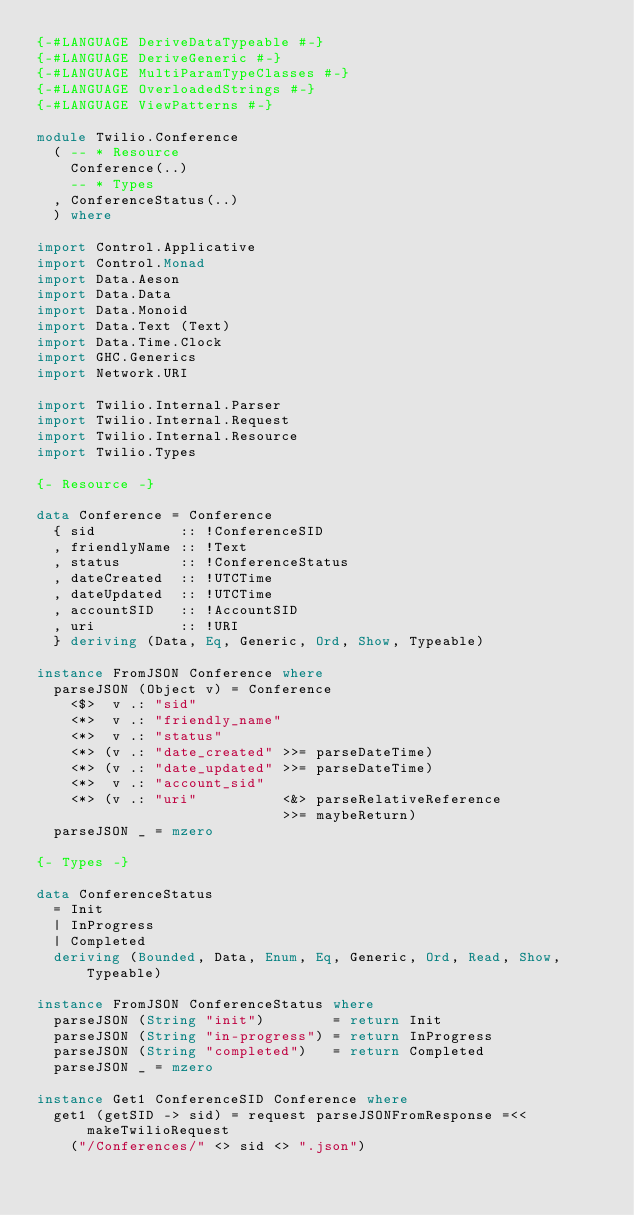Convert code to text. <code><loc_0><loc_0><loc_500><loc_500><_Haskell_>{-#LANGUAGE DeriveDataTypeable #-}
{-#LANGUAGE DeriveGeneric #-}
{-#LANGUAGE MultiParamTypeClasses #-}
{-#LANGUAGE OverloadedStrings #-}
{-#LANGUAGE ViewPatterns #-}

module Twilio.Conference
  ( -- * Resource
    Conference(..)
    -- * Types
  , ConferenceStatus(..)
  ) where

import Control.Applicative
import Control.Monad
import Data.Aeson
import Data.Data
import Data.Monoid
import Data.Text (Text)
import Data.Time.Clock
import GHC.Generics
import Network.URI

import Twilio.Internal.Parser
import Twilio.Internal.Request
import Twilio.Internal.Resource
import Twilio.Types

{- Resource -}

data Conference = Conference
  { sid          :: !ConferenceSID
  , friendlyName :: !Text
  , status       :: !ConferenceStatus
  , dateCreated  :: !UTCTime
  , dateUpdated  :: !UTCTime
  , accountSID   :: !AccountSID
  , uri          :: !URI
  } deriving (Data, Eq, Generic, Ord, Show, Typeable)

instance FromJSON Conference where
  parseJSON (Object v) = Conference
    <$>  v .: "sid"
    <*>  v .: "friendly_name"
    <*>  v .: "status"
    <*> (v .: "date_created" >>= parseDateTime)
    <*> (v .: "date_updated" >>= parseDateTime)
    <*>  v .: "account_sid"
    <*> (v .: "uri"          <&> parseRelativeReference
                             >>= maybeReturn)
  parseJSON _ = mzero

{- Types -}

data ConferenceStatus
  = Init
  | InProgress
  | Completed
  deriving (Bounded, Data, Enum, Eq, Generic, Ord, Read, Show, Typeable)

instance FromJSON ConferenceStatus where
  parseJSON (String "init")        = return Init
  parseJSON (String "in-progress") = return InProgress
  parseJSON (String "completed")   = return Completed
  parseJSON _ = mzero

instance Get1 ConferenceSID Conference where
  get1 (getSID -> sid) = request parseJSONFromResponse =<< makeTwilioRequest
    ("/Conferences/" <> sid <> ".json")
</code> 